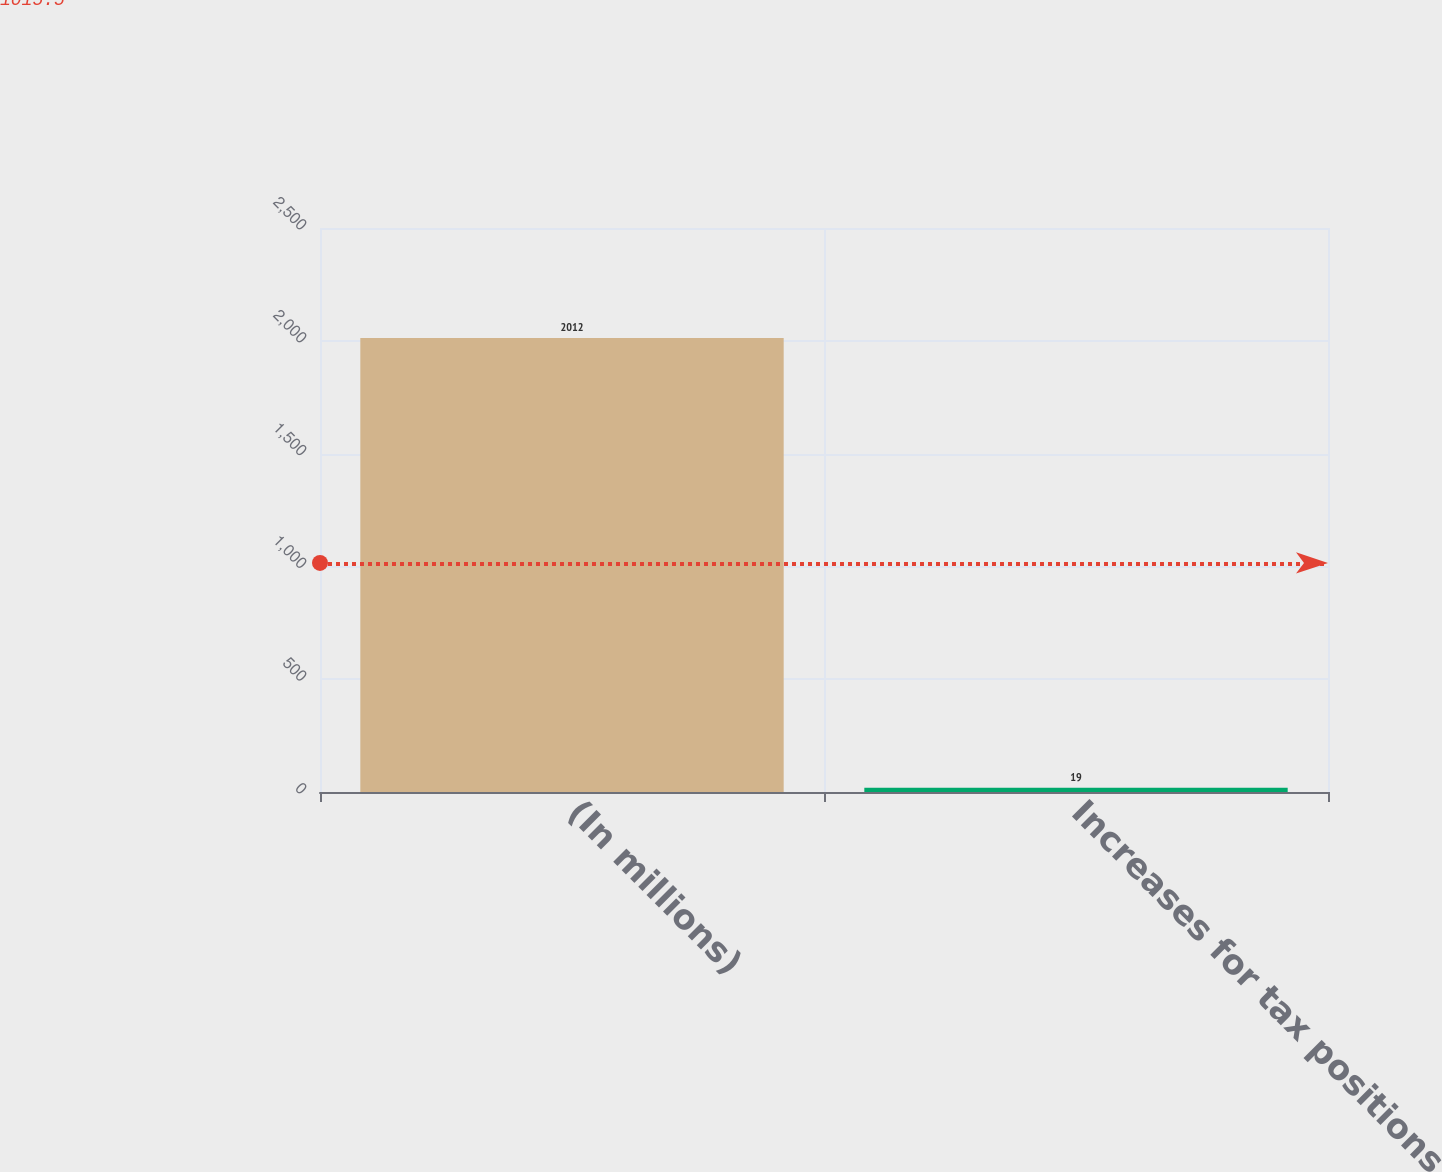Convert chart to OTSL. <chart><loc_0><loc_0><loc_500><loc_500><bar_chart><fcel>(In millions)<fcel>Increases for tax positions<nl><fcel>2012<fcel>19<nl></chart> 